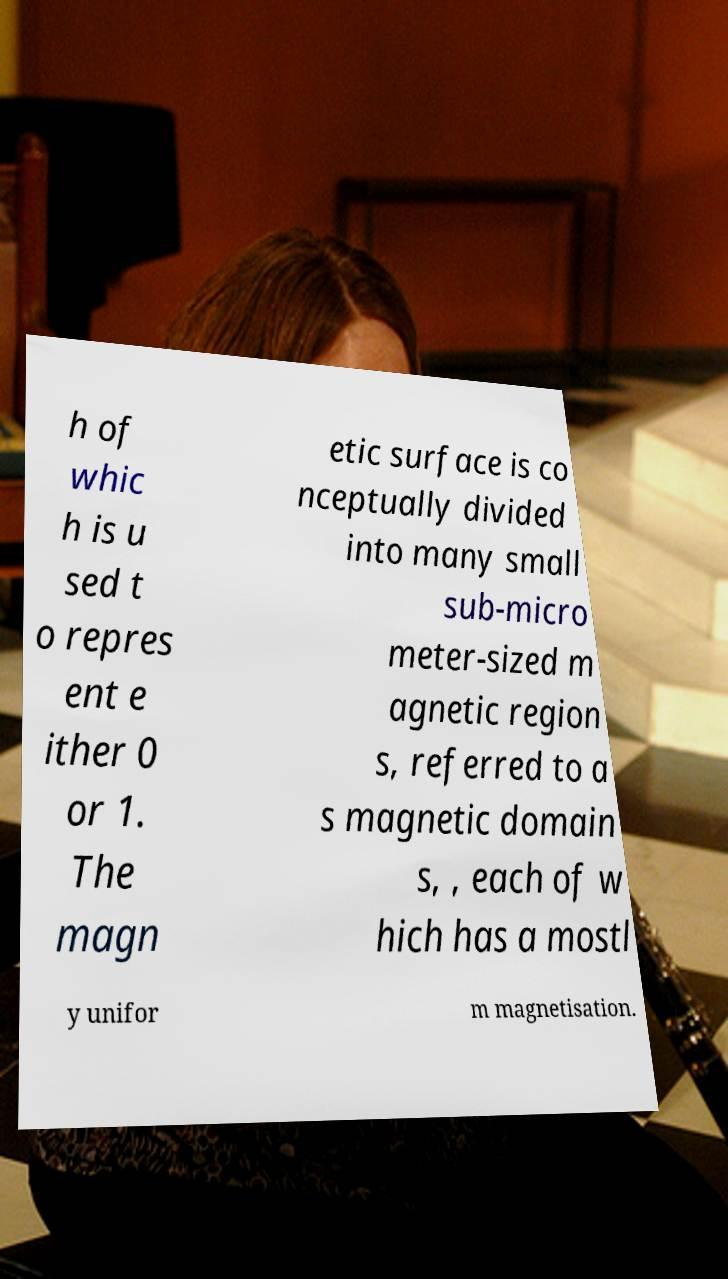There's text embedded in this image that I need extracted. Can you transcribe it verbatim? h of whic h is u sed t o repres ent e ither 0 or 1. The magn etic surface is co nceptually divided into many small sub-micro meter-sized m agnetic region s, referred to a s magnetic domain s, , each of w hich has a mostl y unifor m magnetisation. 